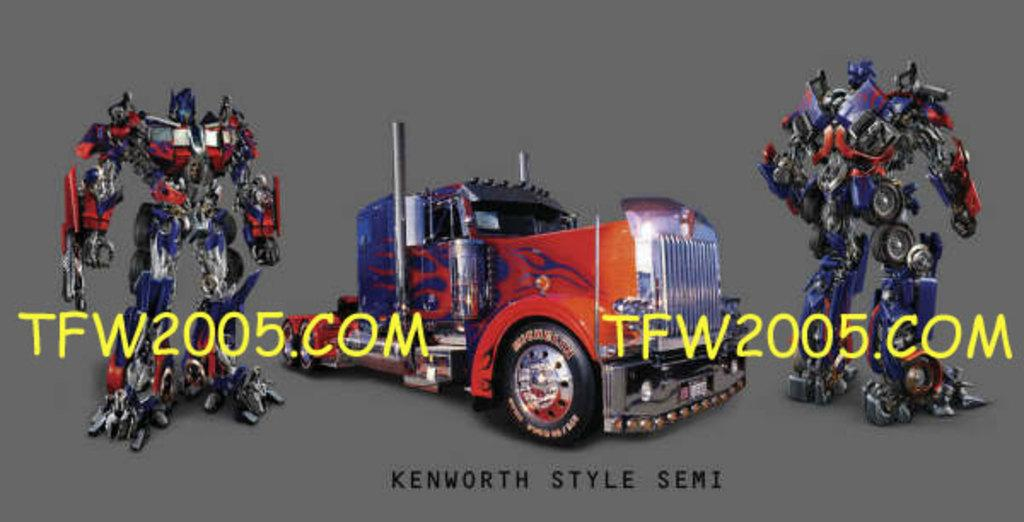What type of objects are present in the image? There are toys in the image. Can you identify any specific toy in the image? Yes, there is a car toy in the image. Are there any retort toys in the image? Yes, there are two retort toys in the image, one on the left side and one on the right side. Is there any text visible in the image? Yes, there is text visible in the image. What type of coal can be seen on the island in the image? There is no island or coal present in the image; it features toys and text. Are there any police officers visible in the image? No, there are no police officers present in the image. 